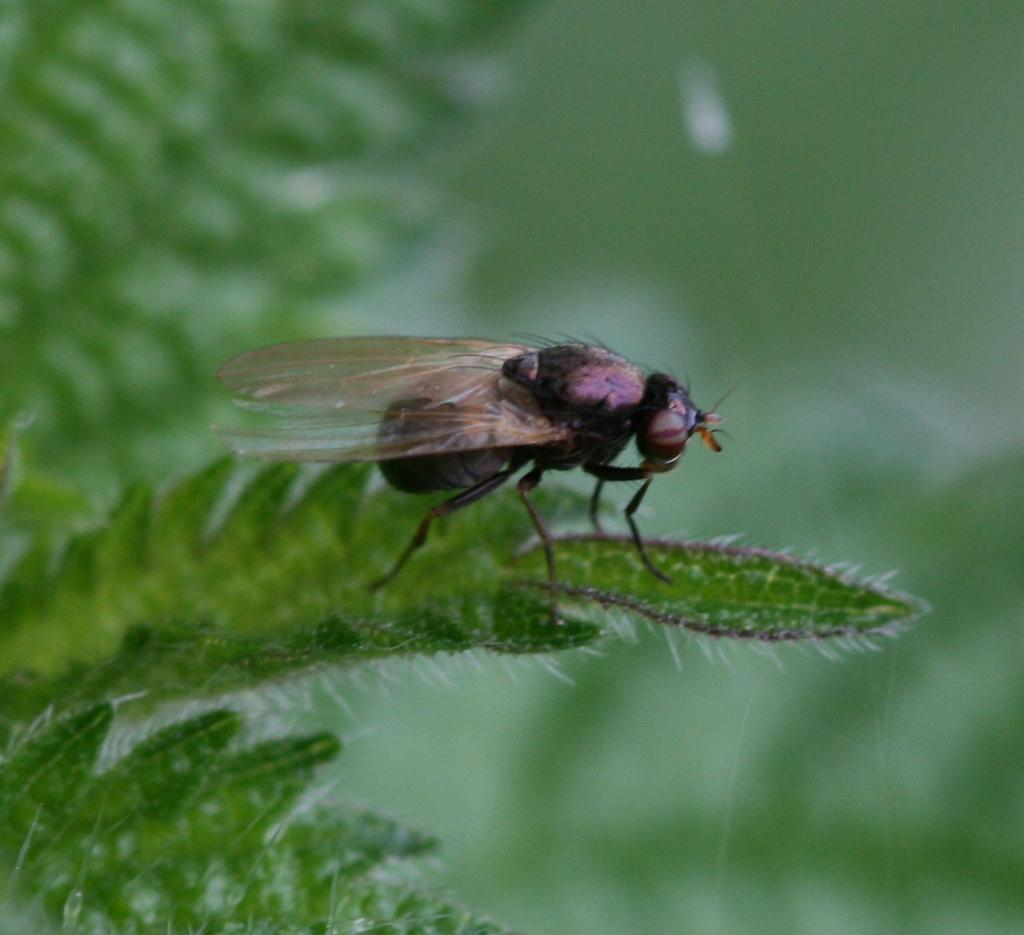What type of creature can be seen on the leaves in the image? There is an insect on the leaves in the image. Can you describe the background of the image? The background of the image is blurred. What type of rock can be seen in the image? There is no rock present in the image. What type of beetle can be seen in the image? The image does not show a beetle; it features an insect on the leaves. What is the source of light in the image? The provided facts do not mention the source of light in the image, so it cannot be determined from the image. 